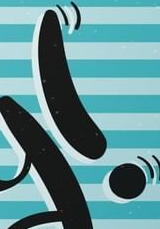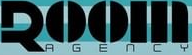Transcribe the words shown in these images in order, separated by a semicolon. !; ROOM 